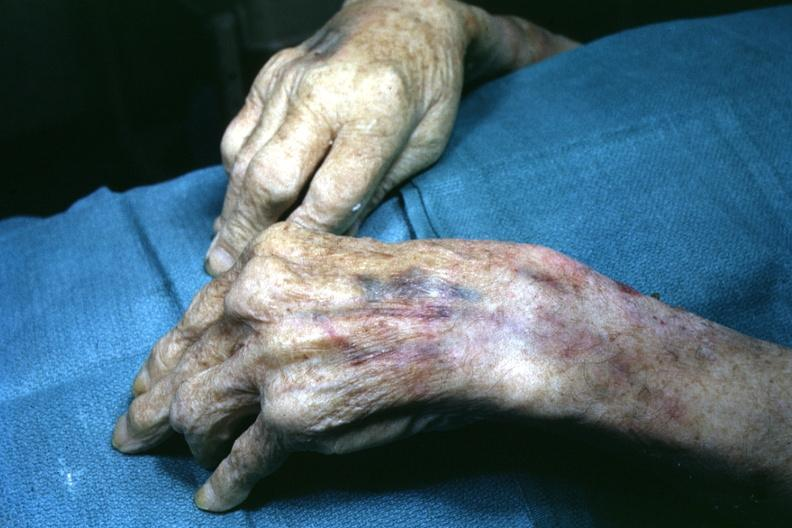does this image show view of both hand with enlarged joints?
Answer the question using a single word or phrase. Yes 